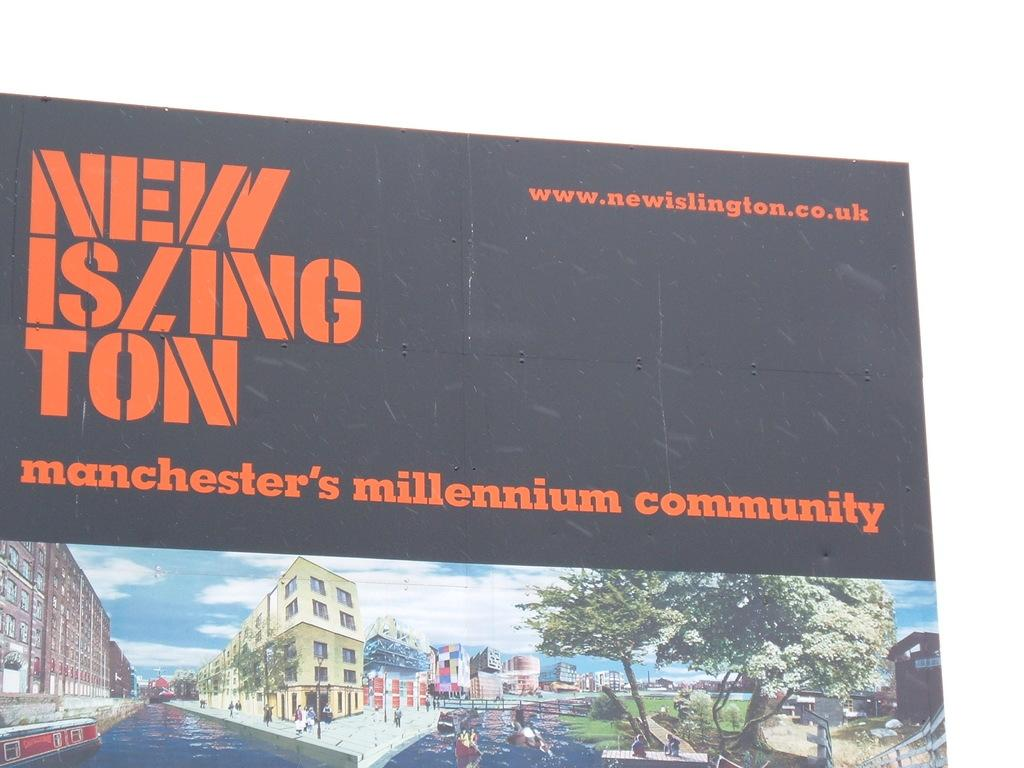Provide a one-sentence caption for the provided image. A black sign advertises Manchester's millenium community in orange text. 